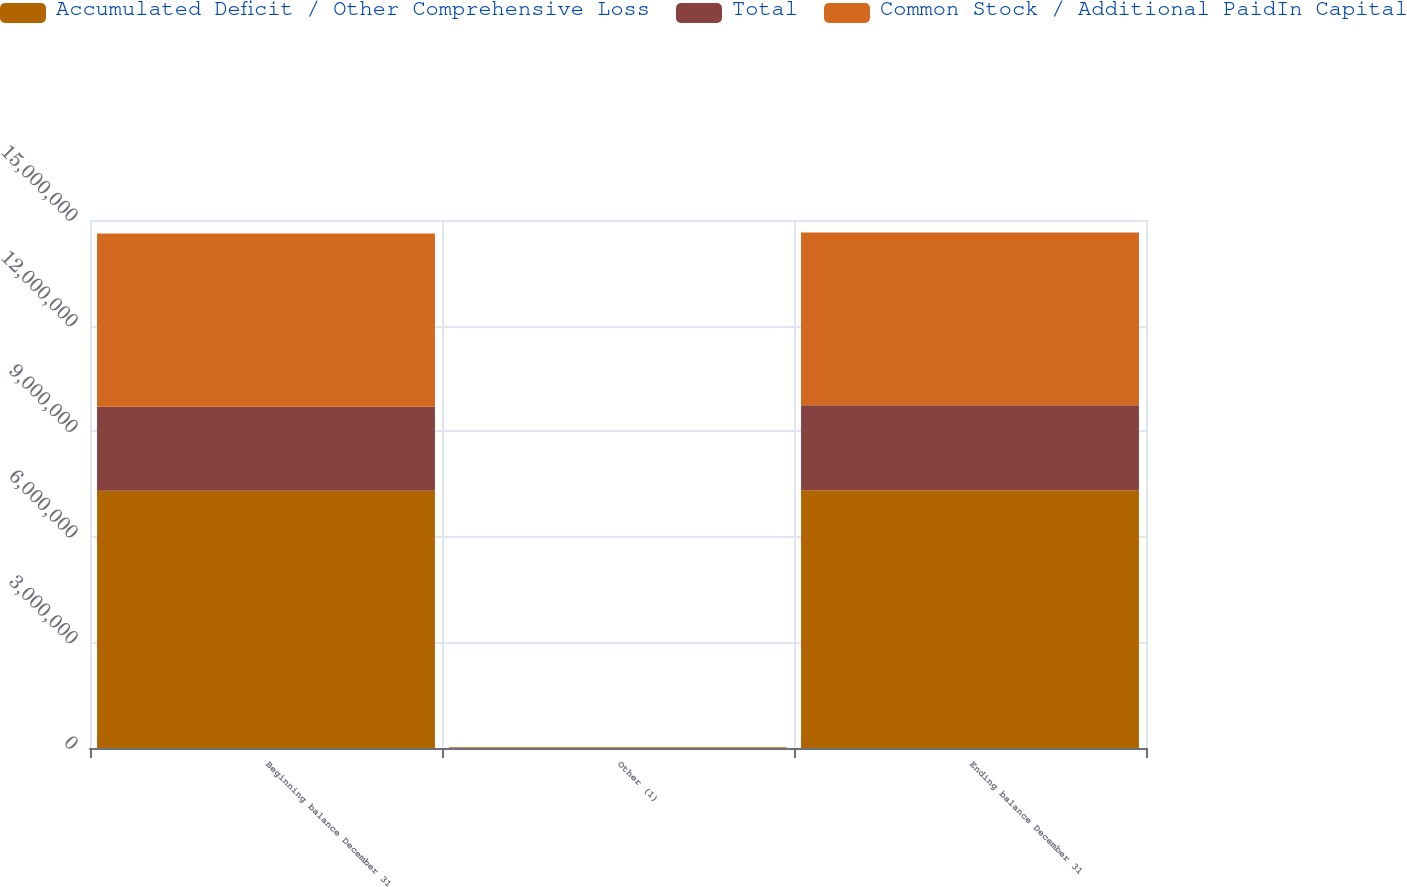<chart> <loc_0><loc_0><loc_500><loc_500><stacked_bar_chart><ecel><fcel>Beginning balance December 31<fcel>Other (1)<fcel>Ending balance December 31<nl><fcel>Accumulated Deficit / Other Comprehensive Loss<fcel>7.30972e+06<fcel>12047<fcel>7.32212e+06<nl><fcel>Total<fcel>2.38177e+06<fcel>2447<fcel>2.41765e+06<nl><fcel>Common Stock / Additional PaidIn Capital<fcel>4.92795e+06<fcel>14494<fcel>4.90447e+06<nl></chart> 